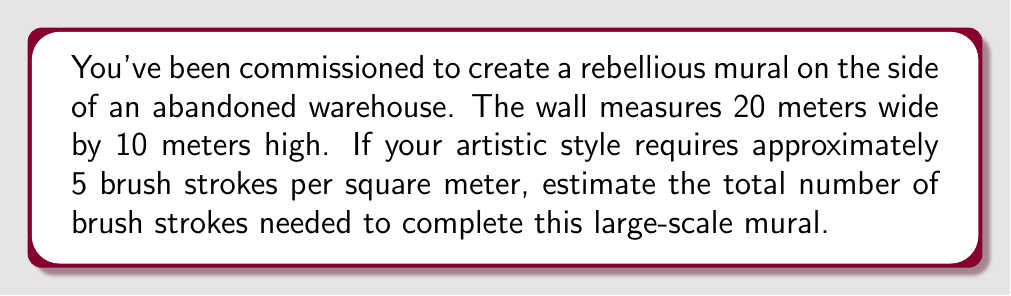Give your solution to this math problem. To estimate the number of brush strokes needed, we'll follow these steps:

1. Calculate the total area of the mural:
   Area = Width × Height
   $$A = 20 \text{ m} \times 10 \text{ m} = 200 \text{ m}^2$$

2. Determine the number of brush strokes per square meter:
   Given in the question as 5 brush strokes per square meter.

3. Calculate the total number of brush strokes:
   Total brush strokes = Area × Brush strokes per square meter
   $$\text{Total brush strokes} = 200 \text{ m}^2 \times 5 \text{ strokes/m}^2 = 1000 \text{ strokes}$$

Therefore, we estimate that approximately 1000 brush strokes will be needed to complete the large-scale mural.
Answer: 1000 brush strokes 